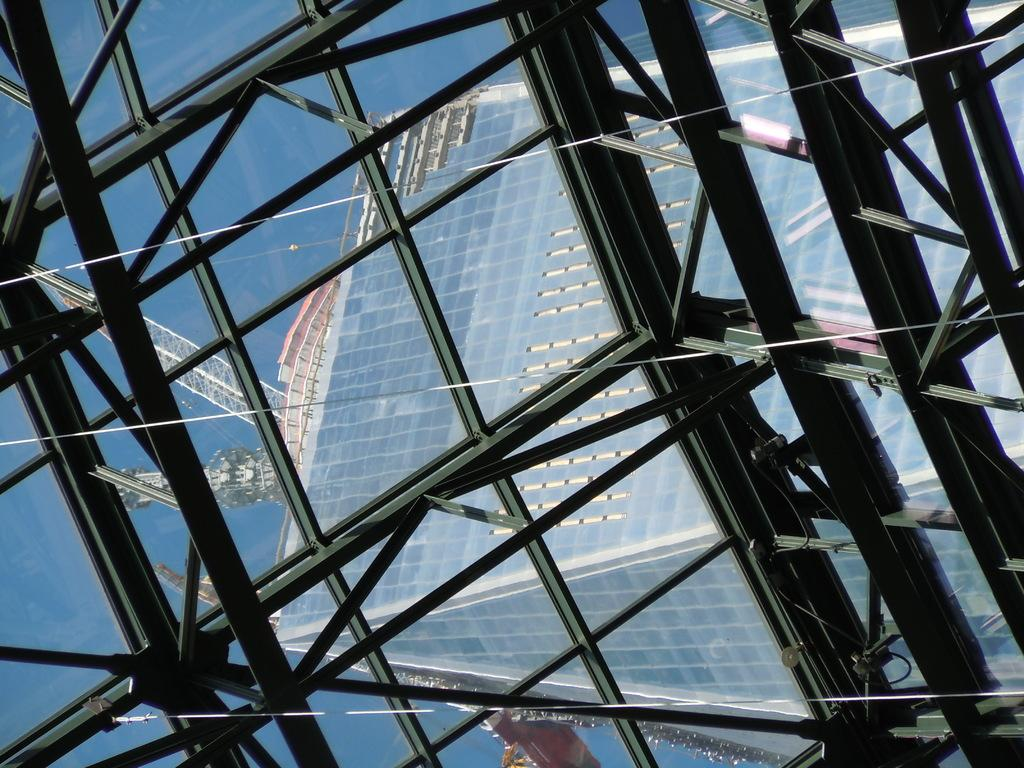What type of structure is present in the image? There is a glass structure in the image. What can be found inside the glass structure? The glass structure contains iron rods. Can you see another glass structure in the image? Yes, another glass structure is visible through the first glass structure. What is visible in the background of the image? The sky is visible in the image. What type of wing can be seen on the glass structure in the image? There are no wings present on the glass structure in the image. 